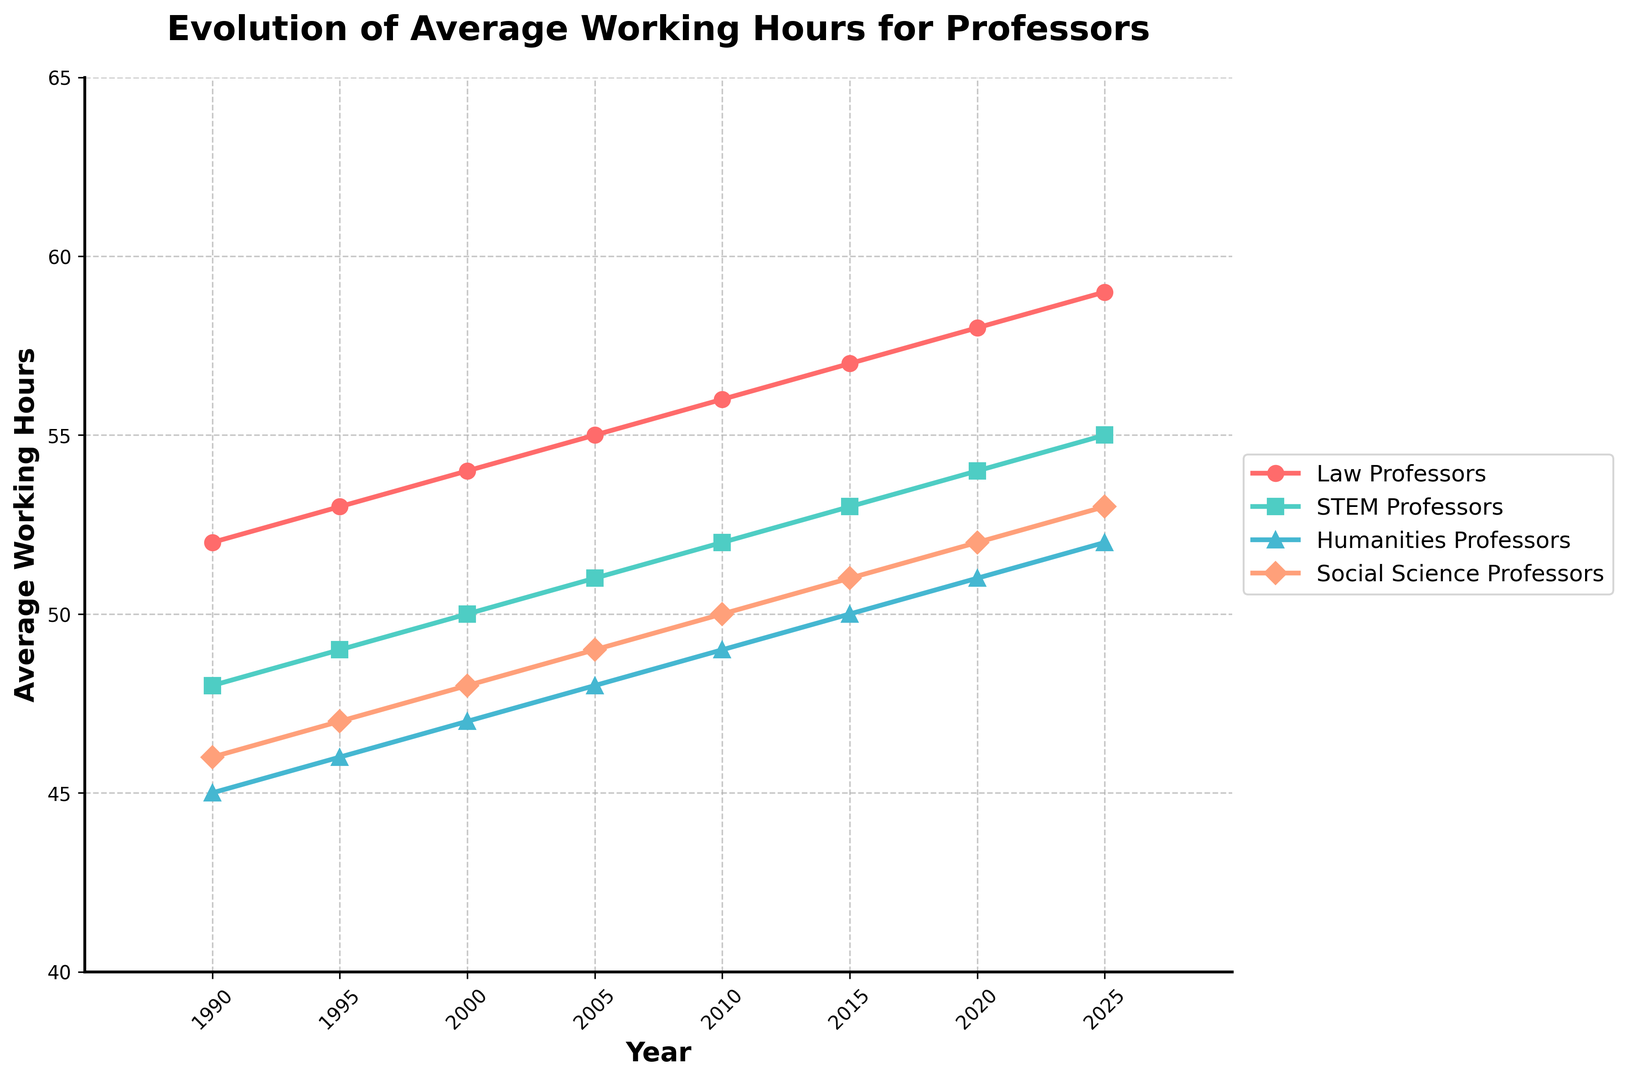What is the difference in average working hours between Law Professors and STEM Professors in 2020? In 2020, Law Professors have an average of 58 working hours, and STEM Professors have 54. The difference is obtained by subtraction: 58 - 54.
Answer: 4 hours Which profession had the most significant increase in average working hours from 1990 to 2025? By comparing the increase in working hours for all professions, we have:
- Law Professors: 59 - 52 = 7
- STEM Professors: 55 - 48 = 7
- Humanities Professors: 52 - 45 = 7
- Social Science Professors: 53 - 46 = 7
All professions had an equal increase of 7 hours.
Answer: All equally, 7 hours In which year did Law Professors surpass 55 average working hours? Reviewing the data, this occurred in 2010 when the average working hours reached 56.
Answer: 2010 What is the average working hours of Humanities Professors in 2015, and how does it compare to that of Social Science Professors in the same year? Humanities Professors worked 50 hours, while Social Science Professors worked 51 hours in 2015. Humanities Professors worked one hour less than Social Science Professors.
Answer: 50 hours, 1 hour less Between 2000 and 2015, which profession's working hours increased the most? From 2000 to 2015, the increase per profession was:
- Law Professors: 57 - 54 = 3
- STEM Professors: 53 - 50 = 3
- Humanities Professors: 50 - 47 = 3
- Social Science Professors: 51 - 48 = 3
All professions had an equal increase of 3 hours.
Answer: All equally, 3 hours What was the rate of increase in average working hours per year for Social Science Professors between 1990 and 2025? Over 35 years (2025 - 1990), the working hours for Social Science Professors increased by 7 (53 - 46). The rate of increase is obtained by dividing the total increase by the number of years: 7 / 35.
Answer: 0.2 hours/year Which profession had the least average working hours in 1990, and how many hours was it? In 1990, Humanities Professors had the least average working hours at 45 hours.
Answer: Humanities Professors, 45 hours What is the visual attribute difference between the line representing Law Professors and STEM Professors? The line for Law Professors is represented in red with circle markers, while the STEM Professors' line is represented in turquoise with square markers.
Answer: Red with circles, Turquoise with squares 